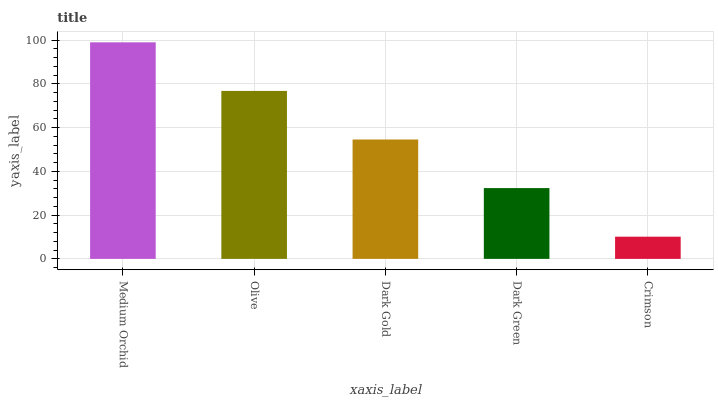Is Crimson the minimum?
Answer yes or no. Yes. Is Medium Orchid the maximum?
Answer yes or no. Yes. Is Olive the minimum?
Answer yes or no. No. Is Olive the maximum?
Answer yes or no. No. Is Medium Orchid greater than Olive?
Answer yes or no. Yes. Is Olive less than Medium Orchid?
Answer yes or no. Yes. Is Olive greater than Medium Orchid?
Answer yes or no. No. Is Medium Orchid less than Olive?
Answer yes or no. No. Is Dark Gold the high median?
Answer yes or no. Yes. Is Dark Gold the low median?
Answer yes or no. Yes. Is Olive the high median?
Answer yes or no. No. Is Crimson the low median?
Answer yes or no. No. 